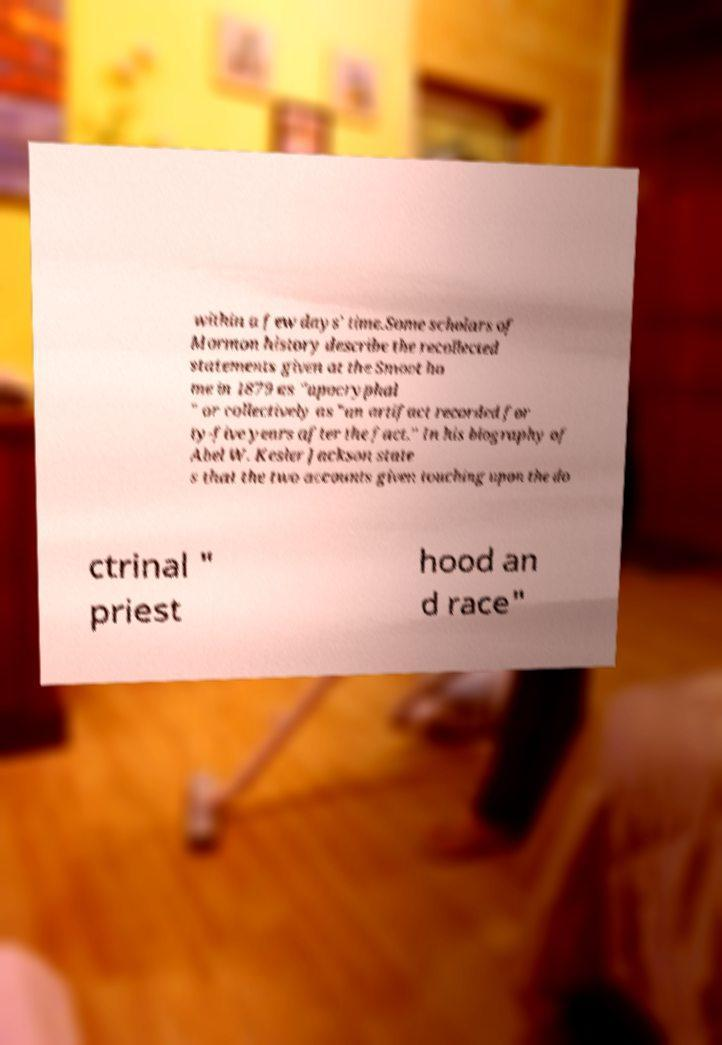Please read and relay the text visible in this image. What does it say? within a few days' time.Some scholars of Mormon history describe the recollected statements given at the Smoot ho me in 1879 as "apocryphal " or collectively as "an artifact recorded for ty-five years after the fact." In his biography of Abel W. Kesler Jackson state s that the two accounts given touching upon the do ctrinal " priest hood an d race" 